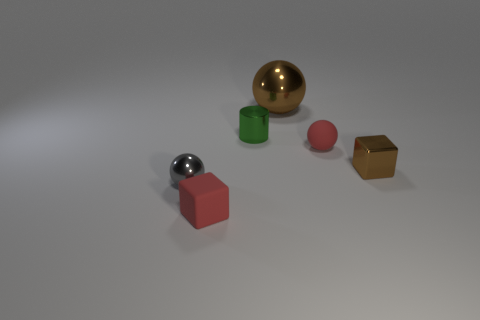Subtract all red rubber spheres. How many spheres are left? 2 Subtract 1 cylinders. How many cylinders are left? 0 Add 4 metallic spheres. How many objects exist? 10 Subtract all brown balls. How many balls are left? 2 Subtract all cylinders. How many objects are left? 5 Add 6 small brown things. How many small brown things exist? 7 Subtract 0 yellow cylinders. How many objects are left? 6 Subtract all blue cylinders. Subtract all yellow blocks. How many cylinders are left? 1 Subtract all brown cylinders. How many red balls are left? 1 Subtract all small brown things. Subtract all red matte objects. How many objects are left? 3 